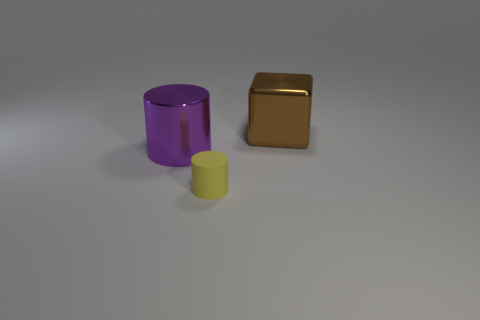Are there any big spheres made of the same material as the yellow cylinder?
Your answer should be compact. No. What is the material of the cube that is the same size as the purple object?
Keep it short and to the point. Metal. What is the size of the object that is behind the rubber cylinder and on the left side of the shiny block?
Offer a very short reply. Large. What is the color of the thing that is both behind the small yellow cylinder and on the left side of the brown metal thing?
Make the answer very short. Purple. Are there fewer big brown cubes in front of the metal cylinder than big metallic cubes that are in front of the brown thing?
Offer a very short reply. No. How many large metal things are the same shape as the small yellow object?
Your response must be concise. 1. There is a thing that is the same material as the brown block; what size is it?
Make the answer very short. Large. What color is the cylinder that is in front of the big purple shiny cylinder to the left of the small yellow matte cylinder?
Make the answer very short. Yellow. Do the small rubber thing and the metallic thing that is left of the large brown shiny object have the same shape?
Your answer should be compact. Yes. How many brown things are the same size as the yellow rubber object?
Keep it short and to the point. 0. 